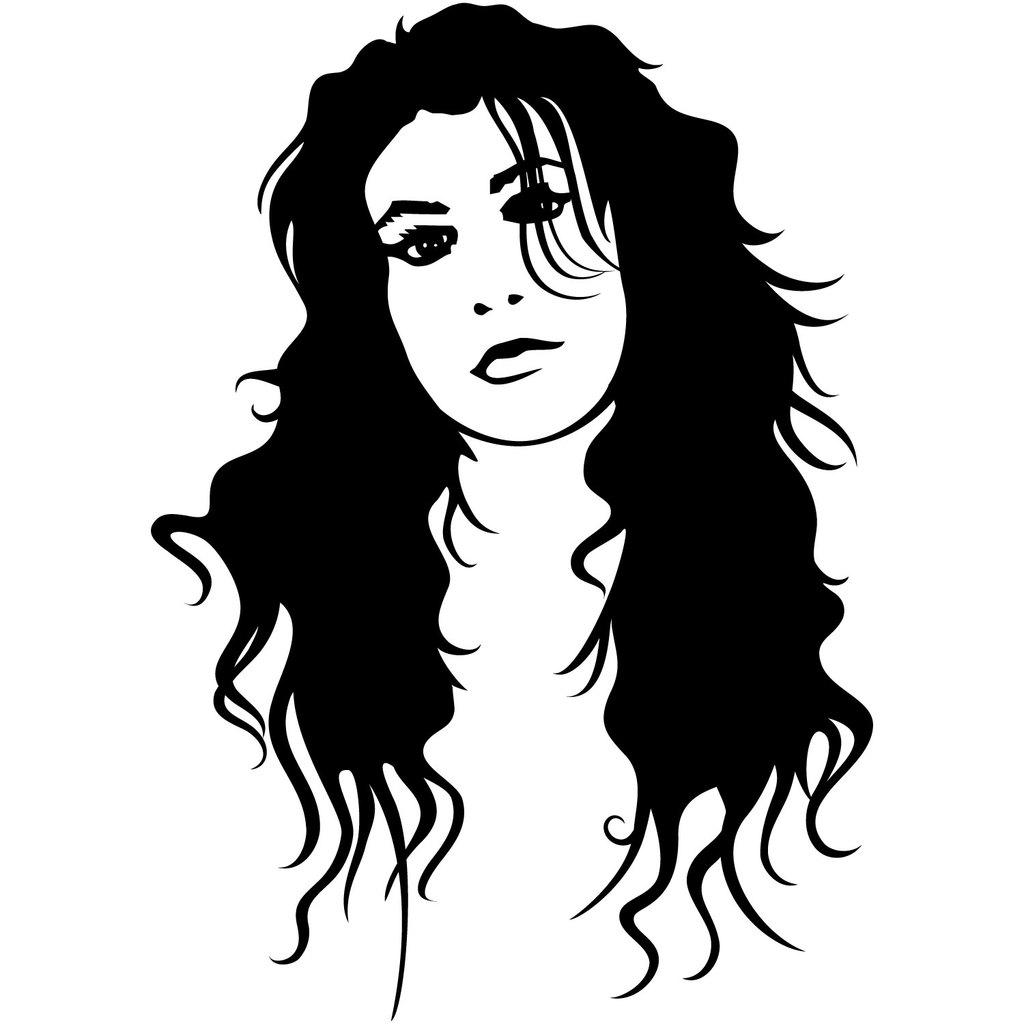What type of image is being described? The image is an animated picture. What can be seen in the animated picture? There is a sketch of a person in the image. What type of hen can be seen in the image? There is no hen present in the image; it features an animated sketch of a person. What scientific experiment is being conducted in the image? There is no scientific experiment depicted in the image; it is an animated sketch of a person. 